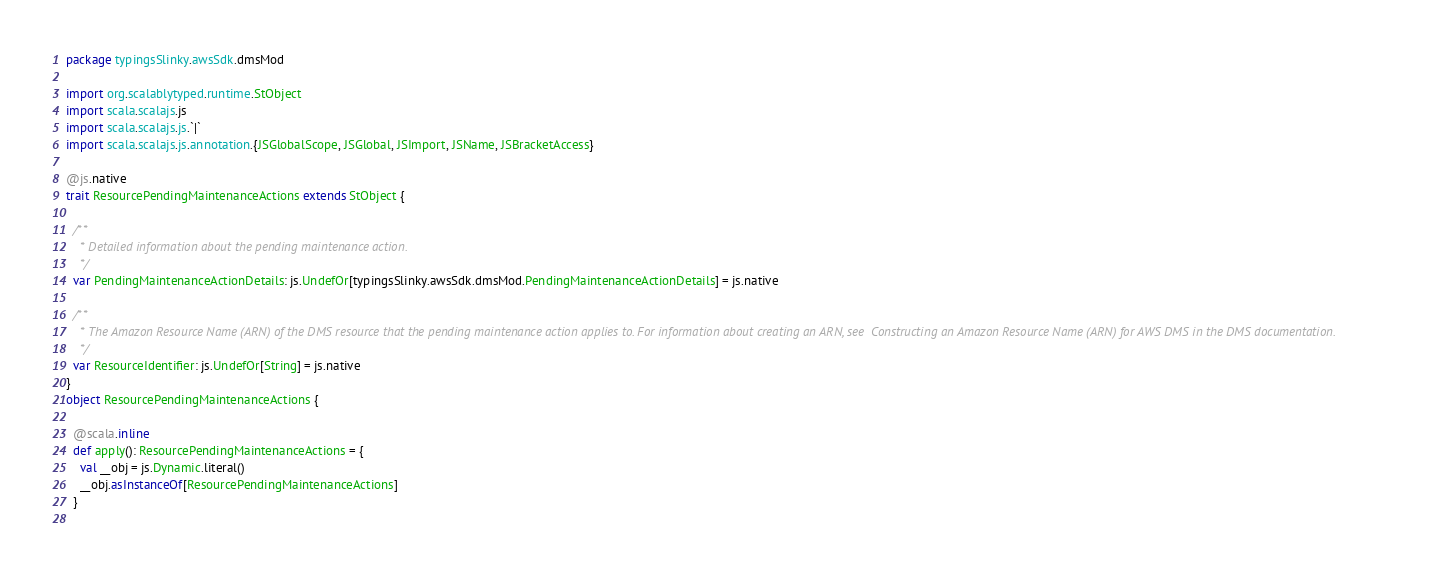<code> <loc_0><loc_0><loc_500><loc_500><_Scala_>package typingsSlinky.awsSdk.dmsMod

import org.scalablytyped.runtime.StObject
import scala.scalajs.js
import scala.scalajs.js.`|`
import scala.scalajs.js.annotation.{JSGlobalScope, JSGlobal, JSImport, JSName, JSBracketAccess}

@js.native
trait ResourcePendingMaintenanceActions extends StObject {
  
  /**
    * Detailed information about the pending maintenance action.
    */
  var PendingMaintenanceActionDetails: js.UndefOr[typingsSlinky.awsSdk.dmsMod.PendingMaintenanceActionDetails] = js.native
  
  /**
    * The Amazon Resource Name (ARN) of the DMS resource that the pending maintenance action applies to. For information about creating an ARN, see  Constructing an Amazon Resource Name (ARN) for AWS DMS in the DMS documentation.
    */
  var ResourceIdentifier: js.UndefOr[String] = js.native
}
object ResourcePendingMaintenanceActions {
  
  @scala.inline
  def apply(): ResourcePendingMaintenanceActions = {
    val __obj = js.Dynamic.literal()
    __obj.asInstanceOf[ResourcePendingMaintenanceActions]
  }
  </code> 